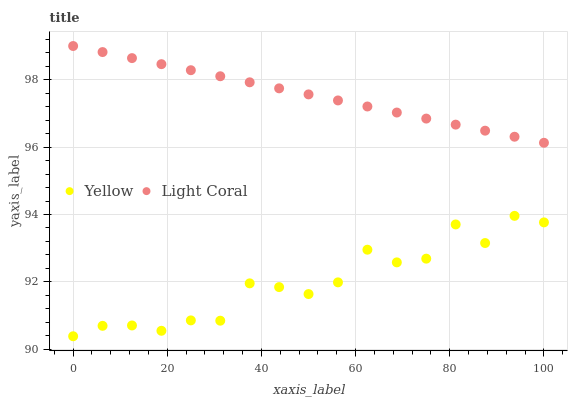Does Yellow have the minimum area under the curve?
Answer yes or no. Yes. Does Light Coral have the maximum area under the curve?
Answer yes or no. Yes. Does Yellow have the maximum area under the curve?
Answer yes or no. No. Is Light Coral the smoothest?
Answer yes or no. Yes. Is Yellow the roughest?
Answer yes or no. Yes. Is Yellow the smoothest?
Answer yes or no. No. Does Yellow have the lowest value?
Answer yes or no. Yes. Does Light Coral have the highest value?
Answer yes or no. Yes. Does Yellow have the highest value?
Answer yes or no. No. Is Yellow less than Light Coral?
Answer yes or no. Yes. Is Light Coral greater than Yellow?
Answer yes or no. Yes. Does Yellow intersect Light Coral?
Answer yes or no. No. 